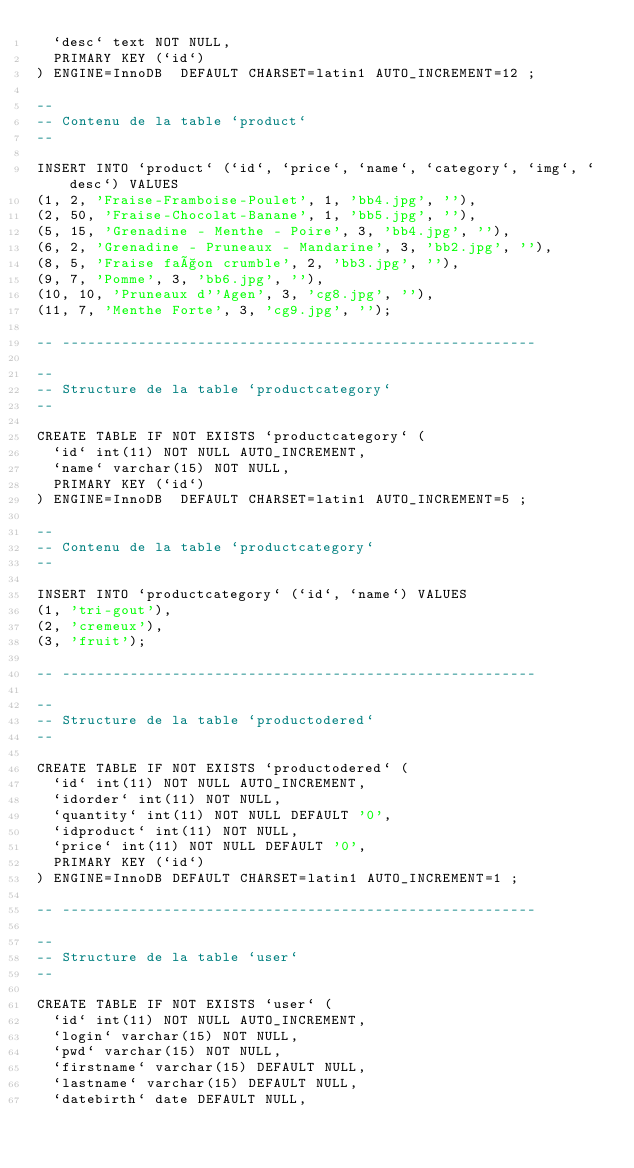<code> <loc_0><loc_0><loc_500><loc_500><_SQL_>  `desc` text NOT NULL,
  PRIMARY KEY (`id`)
) ENGINE=InnoDB  DEFAULT CHARSET=latin1 AUTO_INCREMENT=12 ;

--
-- Contenu de la table `product`
--

INSERT INTO `product` (`id`, `price`, `name`, `category`, `img`, `desc`) VALUES
(1, 2, 'Fraise-Framboise-Poulet', 1, 'bb4.jpg', ''),
(2, 50, 'Fraise-Chocolat-Banane', 1, 'bb5.jpg', ''),
(5, 15, 'Grenadine - Menthe - Poire', 3, 'bb4.jpg', ''),
(6, 2, 'Grenadine - Pruneaux - Mandarine', 3, 'bb2.jpg', ''),
(8, 5, 'Fraise façon crumble', 2, 'bb3.jpg', ''),
(9, 7, 'Pomme', 3, 'bb6.jpg', ''),
(10, 10, 'Pruneaux d''Agen', 3, 'cg8.jpg', ''),
(11, 7, 'Menthe Forte', 3, 'cg9.jpg', '');

-- --------------------------------------------------------

--
-- Structure de la table `productcategory`
--

CREATE TABLE IF NOT EXISTS `productcategory` (
  `id` int(11) NOT NULL AUTO_INCREMENT,
  `name` varchar(15) NOT NULL,
  PRIMARY KEY (`id`)
) ENGINE=InnoDB  DEFAULT CHARSET=latin1 AUTO_INCREMENT=5 ;

--
-- Contenu de la table `productcategory`
--

INSERT INTO `productcategory` (`id`, `name`) VALUES
(1, 'tri-gout'),
(2, 'cremeux'),
(3, 'fruit');

-- --------------------------------------------------------

--
-- Structure de la table `productodered`
--

CREATE TABLE IF NOT EXISTS `productodered` (
  `id` int(11) NOT NULL AUTO_INCREMENT,
  `idorder` int(11) NOT NULL,
  `quantity` int(11) NOT NULL DEFAULT '0',
  `idproduct` int(11) NOT NULL,
  `price` int(11) NOT NULL DEFAULT '0',
  PRIMARY KEY (`id`)
) ENGINE=InnoDB DEFAULT CHARSET=latin1 AUTO_INCREMENT=1 ;

-- --------------------------------------------------------

--
-- Structure de la table `user`
--

CREATE TABLE IF NOT EXISTS `user` (
  `id` int(11) NOT NULL AUTO_INCREMENT,
  `login` varchar(15) NOT NULL,
  `pwd` varchar(15) NOT NULL,
  `firstname` varchar(15) DEFAULT NULL,
  `lastname` varchar(15) DEFAULT NULL,
  `datebirth` date DEFAULT NULL,</code> 